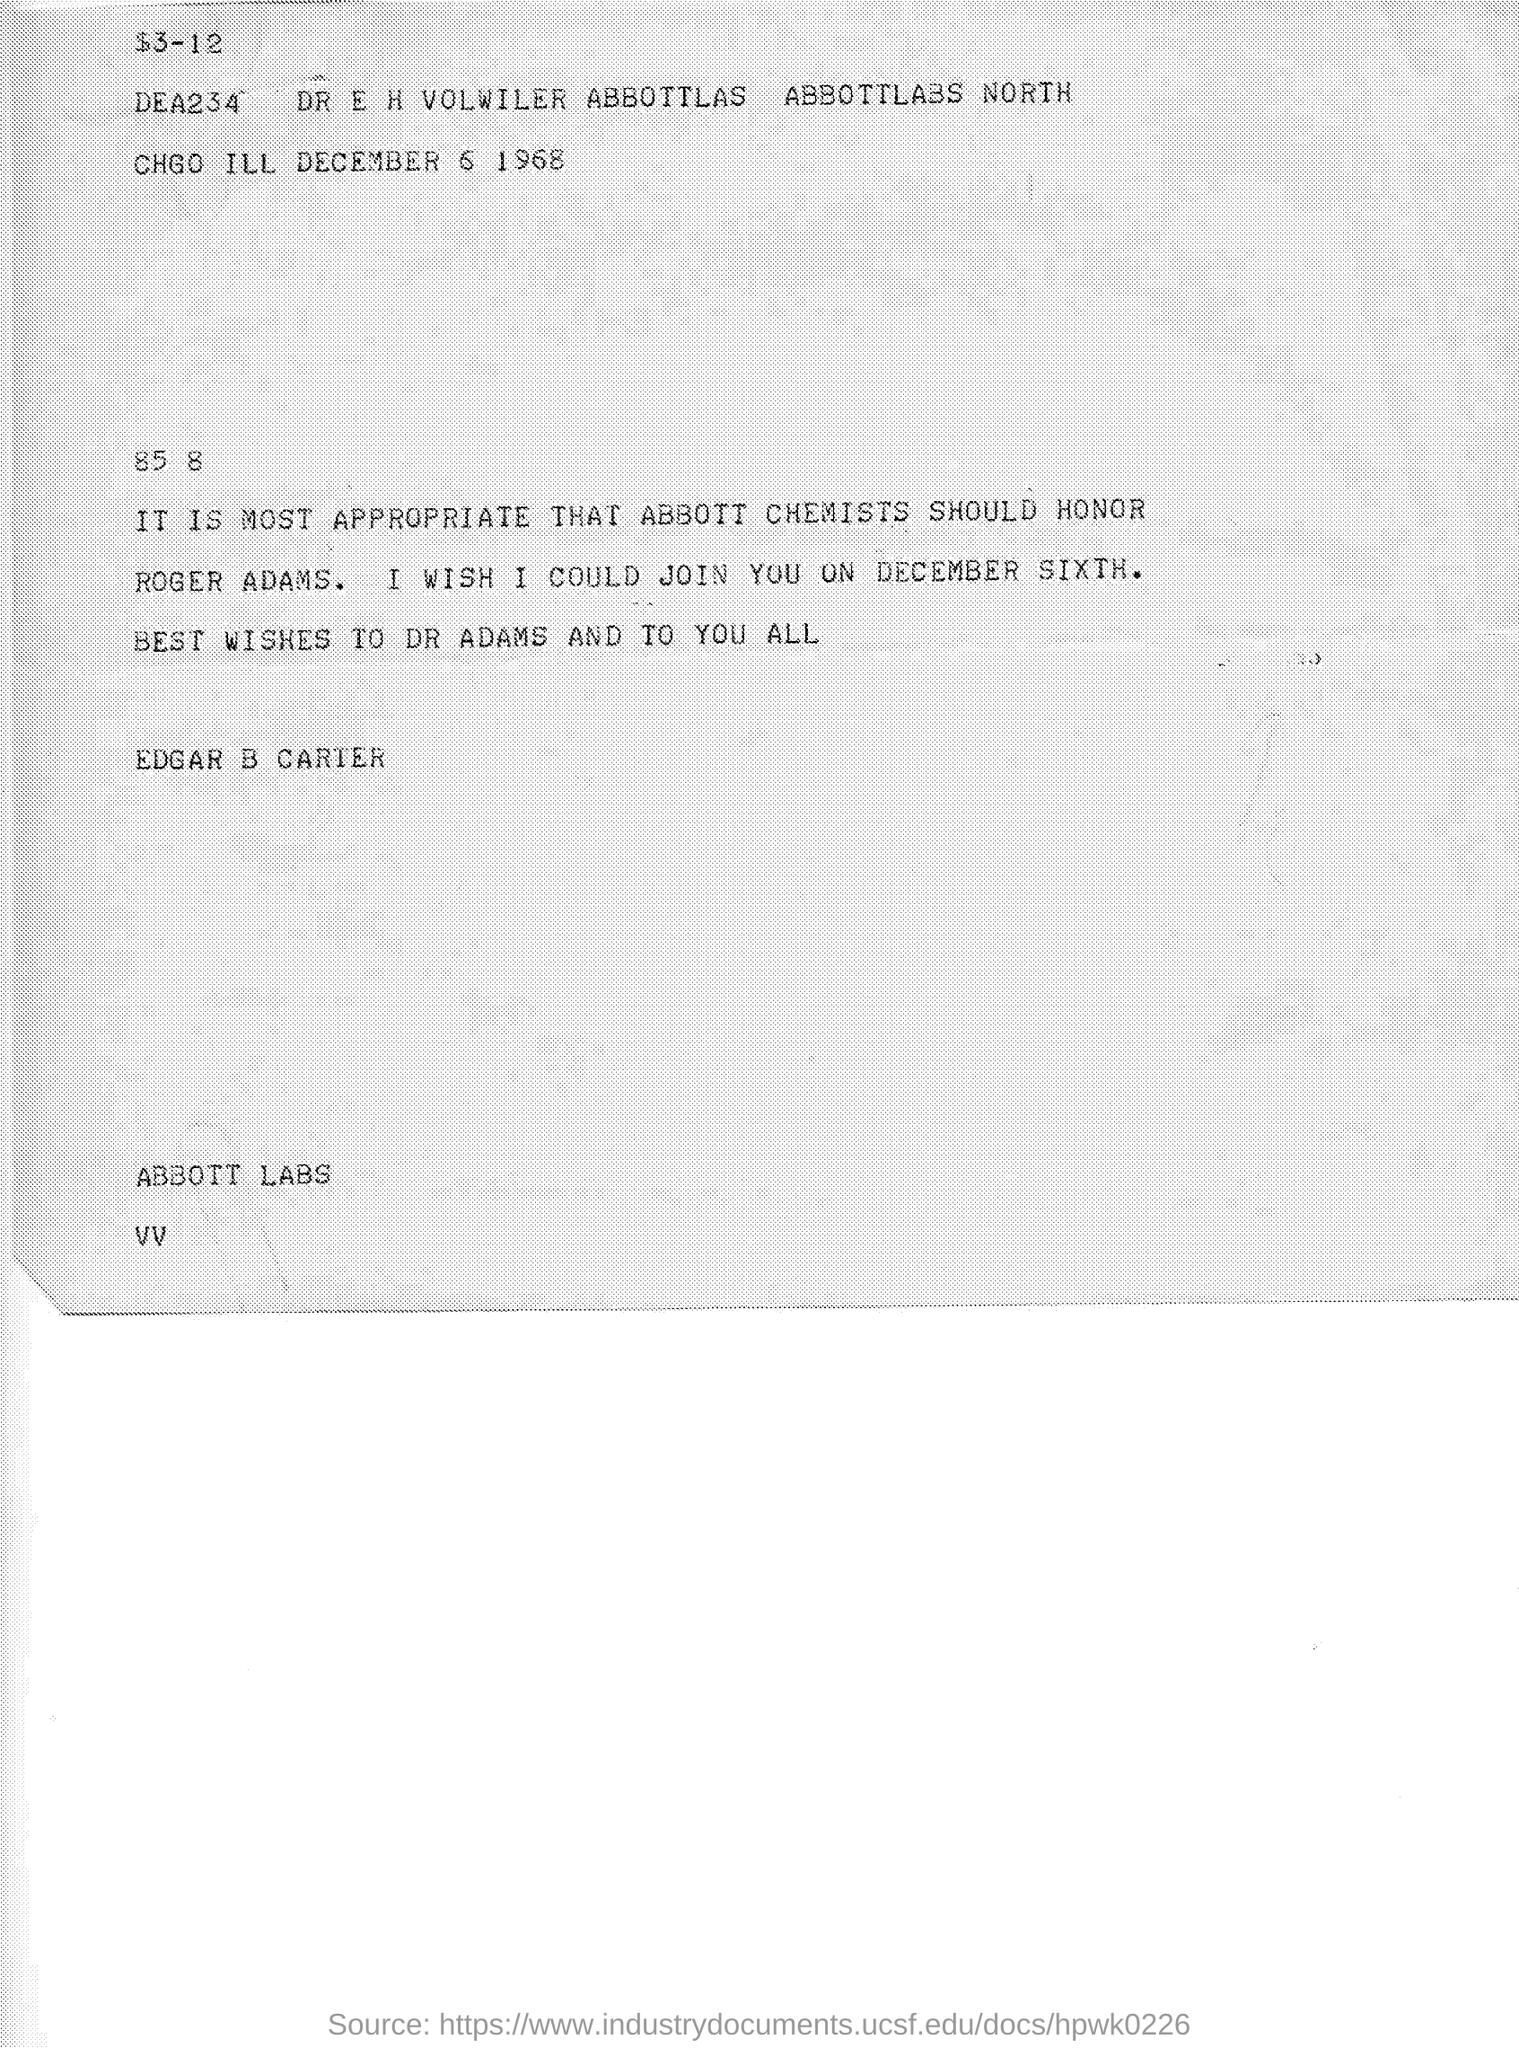List a handful of essential elements in this visual. The program will take place on December 6th. The sender is Edgar B. Carter. The document is dated December 6, 1968. 